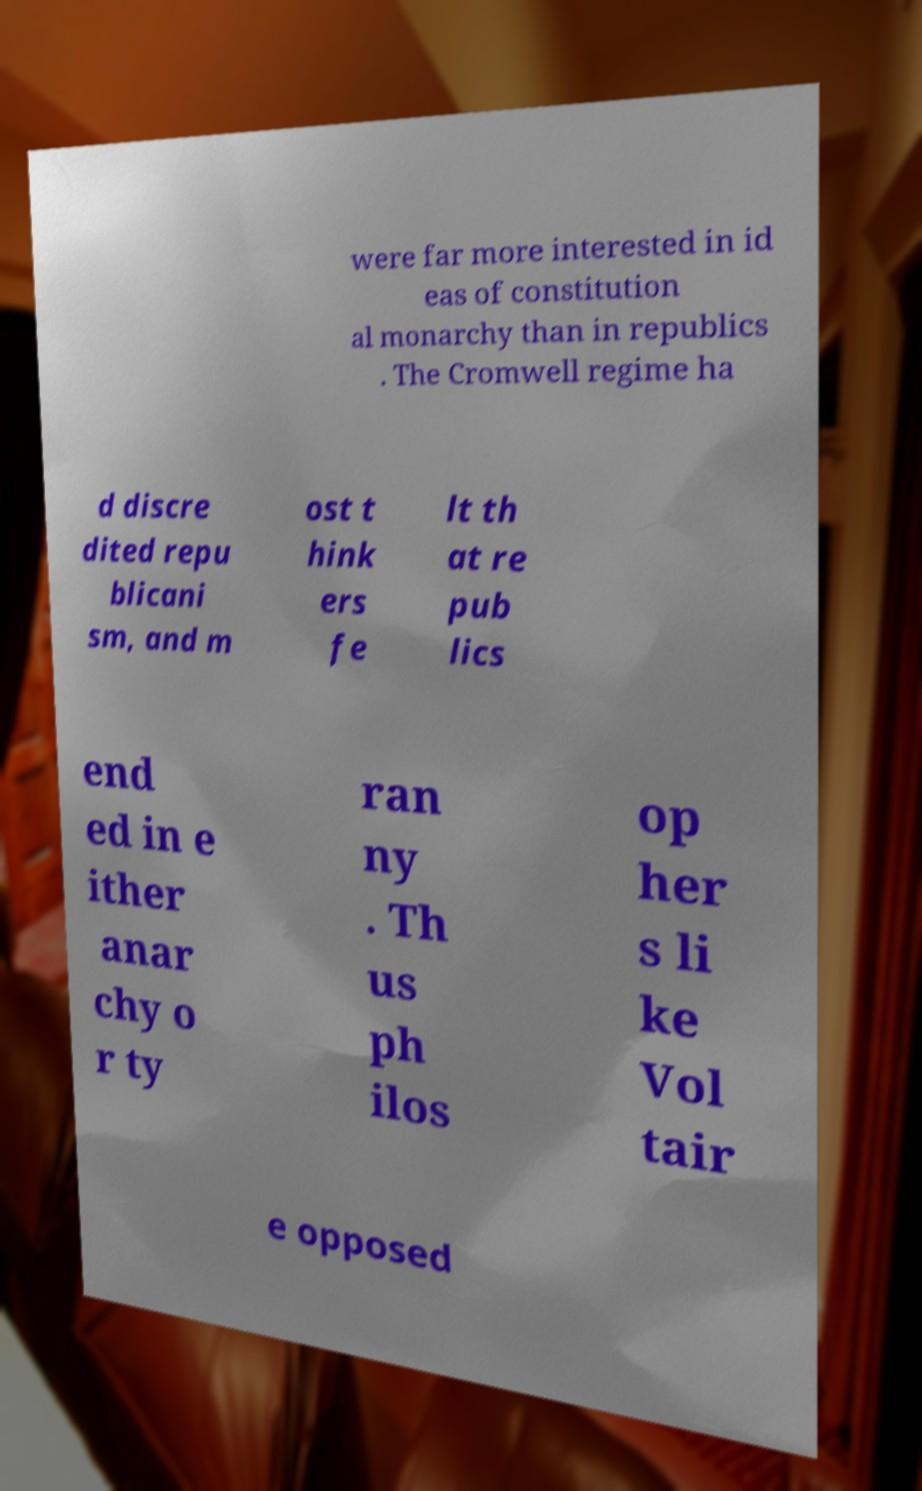Please identify and transcribe the text found in this image. were far more interested in id eas of constitution al monarchy than in republics . The Cromwell regime ha d discre dited repu blicani sm, and m ost t hink ers fe lt th at re pub lics end ed in e ither anar chy o r ty ran ny . Th us ph ilos op her s li ke Vol tair e opposed 